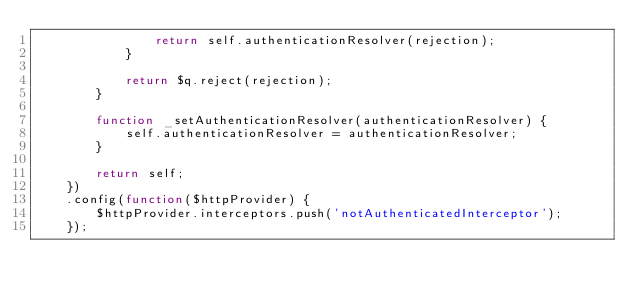<code> <loc_0><loc_0><loc_500><loc_500><_JavaScript_>                return self.authenticationResolver(rejection);
            }

            return $q.reject(rejection);
        }

        function _setAuthenticationResolver(authenticationResolver) {
            self.authenticationResolver = authenticationResolver;
        }

        return self;
    })
    .config(function($httpProvider) {
        $httpProvider.interceptors.push('notAuthenticatedInterceptor');
    });</code> 